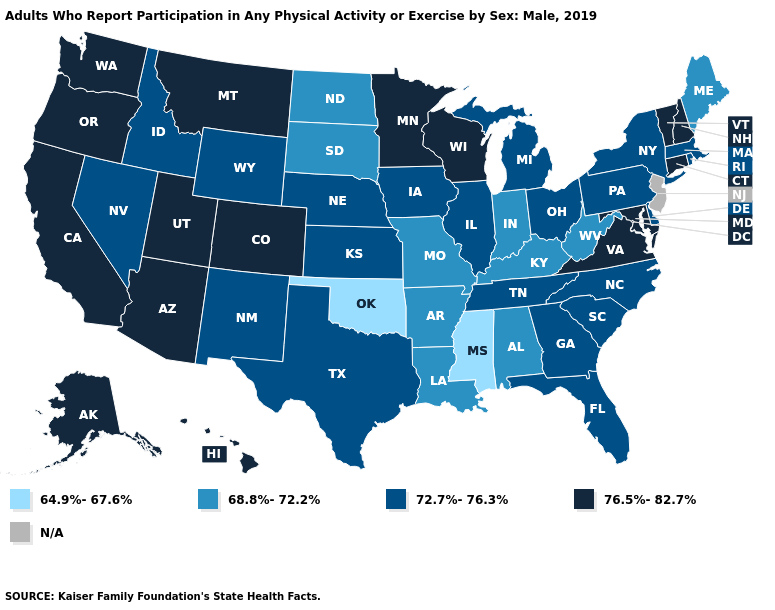Does the map have missing data?
Give a very brief answer. Yes. Name the states that have a value in the range 64.9%-67.6%?
Write a very short answer. Mississippi, Oklahoma. Name the states that have a value in the range 72.7%-76.3%?
Keep it brief. Delaware, Florida, Georgia, Idaho, Illinois, Iowa, Kansas, Massachusetts, Michigan, Nebraska, Nevada, New Mexico, New York, North Carolina, Ohio, Pennsylvania, Rhode Island, South Carolina, Tennessee, Texas, Wyoming. What is the value of Michigan?
Be succinct. 72.7%-76.3%. Which states have the highest value in the USA?
Concise answer only. Alaska, Arizona, California, Colorado, Connecticut, Hawaii, Maryland, Minnesota, Montana, New Hampshire, Oregon, Utah, Vermont, Virginia, Washington, Wisconsin. What is the value of Nevada?
Give a very brief answer. 72.7%-76.3%. What is the value of Kansas?
Give a very brief answer. 72.7%-76.3%. What is the value of New Hampshire?
Answer briefly. 76.5%-82.7%. Does Missouri have the lowest value in the USA?
Give a very brief answer. No. Name the states that have a value in the range 76.5%-82.7%?
Short answer required. Alaska, Arizona, California, Colorado, Connecticut, Hawaii, Maryland, Minnesota, Montana, New Hampshire, Oregon, Utah, Vermont, Virginia, Washington, Wisconsin. Among the states that border Nevada , does California have the lowest value?
Write a very short answer. No. Name the states that have a value in the range 68.8%-72.2%?
Quick response, please. Alabama, Arkansas, Indiana, Kentucky, Louisiana, Maine, Missouri, North Dakota, South Dakota, West Virginia. What is the highest value in the South ?
Give a very brief answer. 76.5%-82.7%. 